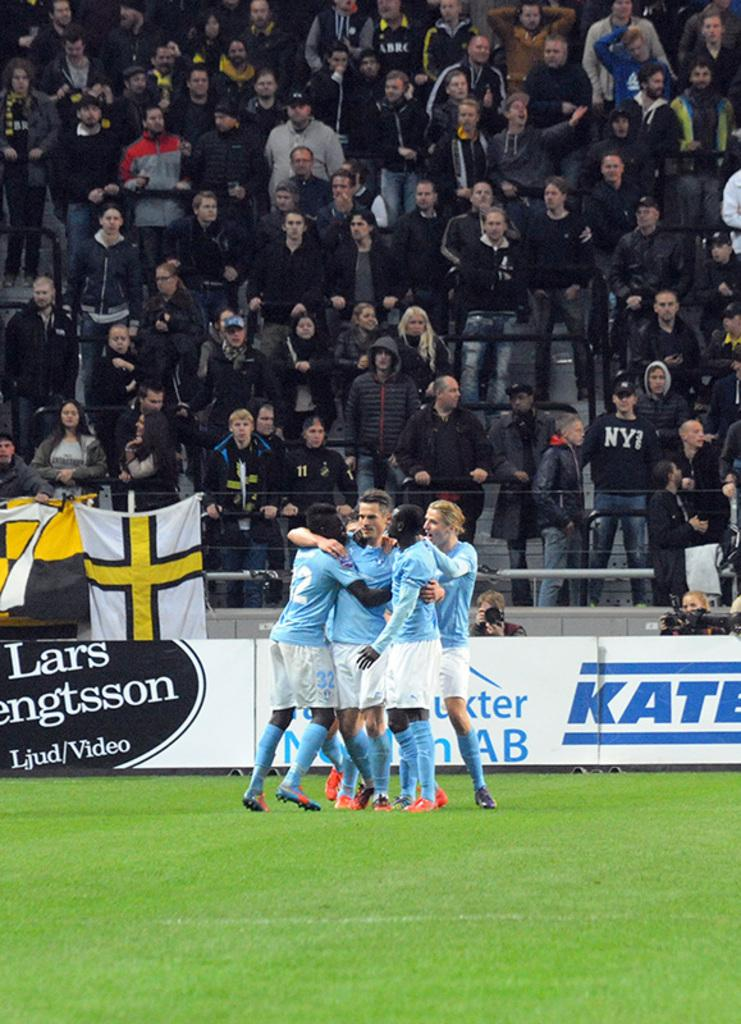What are the people in the image doing? The people in the image are standing on the ground. What else can be seen in the image besides the people? There are hoardings and banners in the image. Can you describe the background of the image? There is a group of people in the background of the image. How many ants can be seen crawling on the frame in the image? There are no ants visible in the image, nor is there a frame present. 